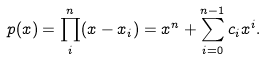Convert formula to latex. <formula><loc_0><loc_0><loc_500><loc_500>p ( x ) = \prod _ { i } ^ { n } ( x - x _ { i } ) = x ^ { n } + \sum _ { i = 0 } ^ { n - 1 } c _ { i } x ^ { i } .</formula> 